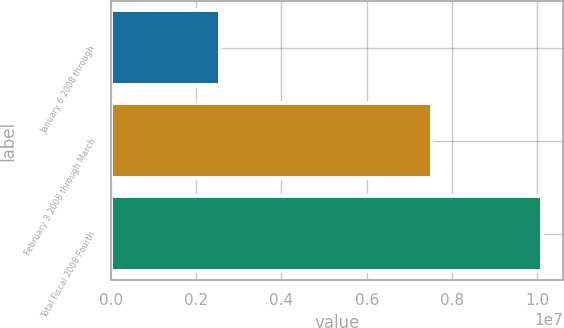Convert chart. <chart><loc_0><loc_0><loc_500><loc_500><bar_chart><fcel>January 6 2008 through<fcel>February 3 2008 through March<fcel>Total Fiscal 2008 Fourth<nl><fcel>2.56733e+06<fcel>7.53905e+06<fcel>1.01064e+07<nl></chart> 